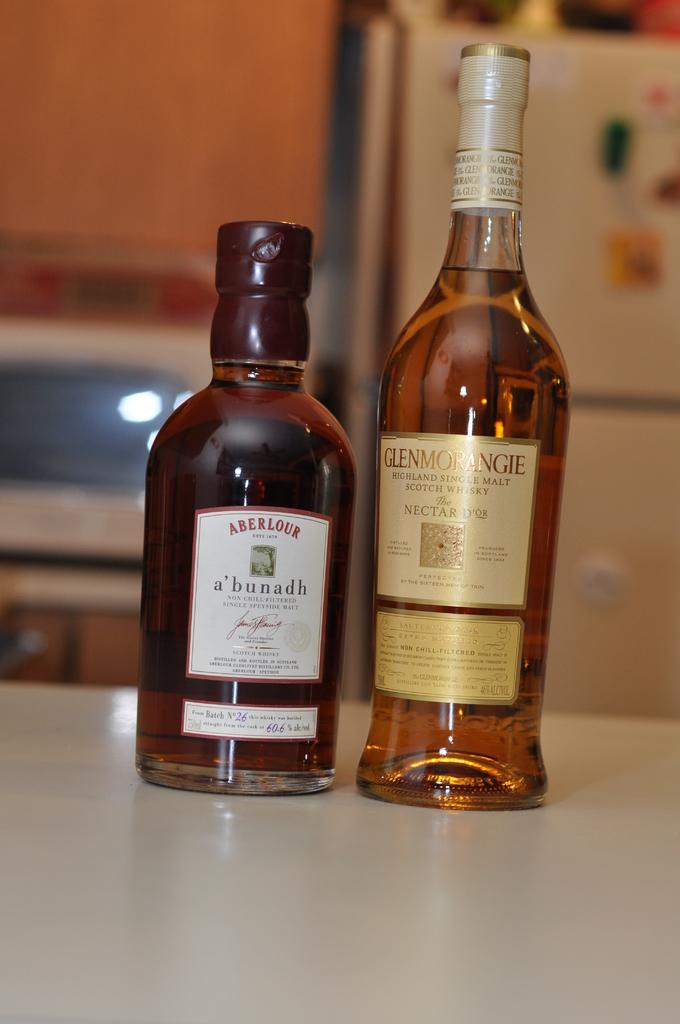Provide a one-sentence caption for the provided image. A bottle of Aberlour alcohol and a bottle of Glenmorangie alcohol. 